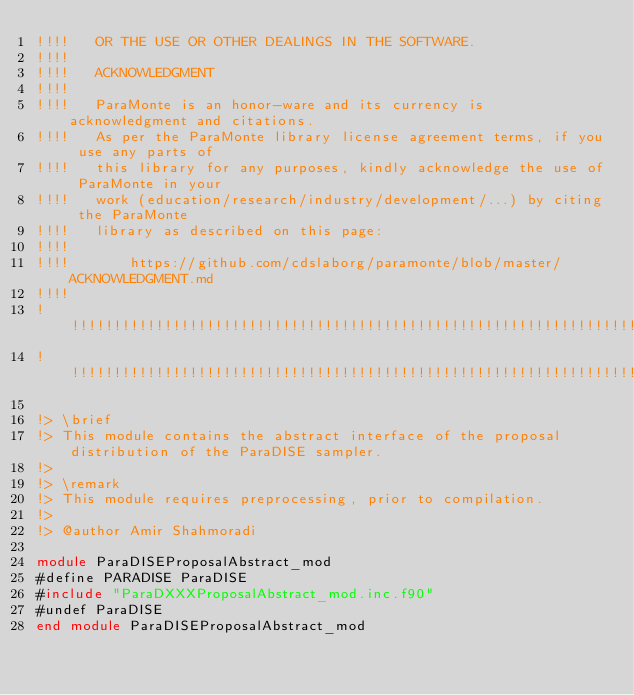Convert code to text. <code><loc_0><loc_0><loc_500><loc_500><_FORTRAN_>!!!!   OR THE USE OR OTHER DEALINGS IN THE SOFTWARE.
!!!!
!!!!   ACKNOWLEDGMENT
!!!!
!!!!   ParaMonte is an honor-ware and its currency is acknowledgment and citations.
!!!!   As per the ParaMonte library license agreement terms, if you use any parts of
!!!!   this library for any purposes, kindly acknowledge the use of ParaMonte in your
!!!!   work (education/research/industry/development/...) by citing the ParaMonte
!!!!   library as described on this page:
!!!!
!!!!       https://github.com/cdslaborg/paramonte/blob/master/ACKNOWLEDGMENT.md
!!!!
!!!!!!!!!!!!!!!!!!!!!!!!!!!!!!!!!!!!!!!!!!!!!!!!!!!!!!!!!!!!!!!!!!!!!!!!!!!!!!!!!!!!!!!!!!!!!!!!!!!!!!!!!!!!!!!!!!!!!!!!!!!!!!!!!!!!
!!!!!!!!!!!!!!!!!!!!!!!!!!!!!!!!!!!!!!!!!!!!!!!!!!!!!!!!!!!!!!!!!!!!!!!!!!!!!!!!!!!!!!!!!!!!!!!!!!!!!!!!!!!!!!!!!!!!!!!!!!!!!!!!!!!!

!> \brief
!> This module contains the abstract interface of the proposal distribution of the ParaDISE sampler.
!>
!> \remark
!> This module requires preprocessing, prior to compilation.
!>
!> @author Amir Shahmoradi

module ParaDISEProposalAbstract_mod
#define PARADISE ParaDISE
#include "ParaDXXXProposalAbstract_mod.inc.f90"
#undef ParaDISE
end module ParaDISEProposalAbstract_mod

</code> 